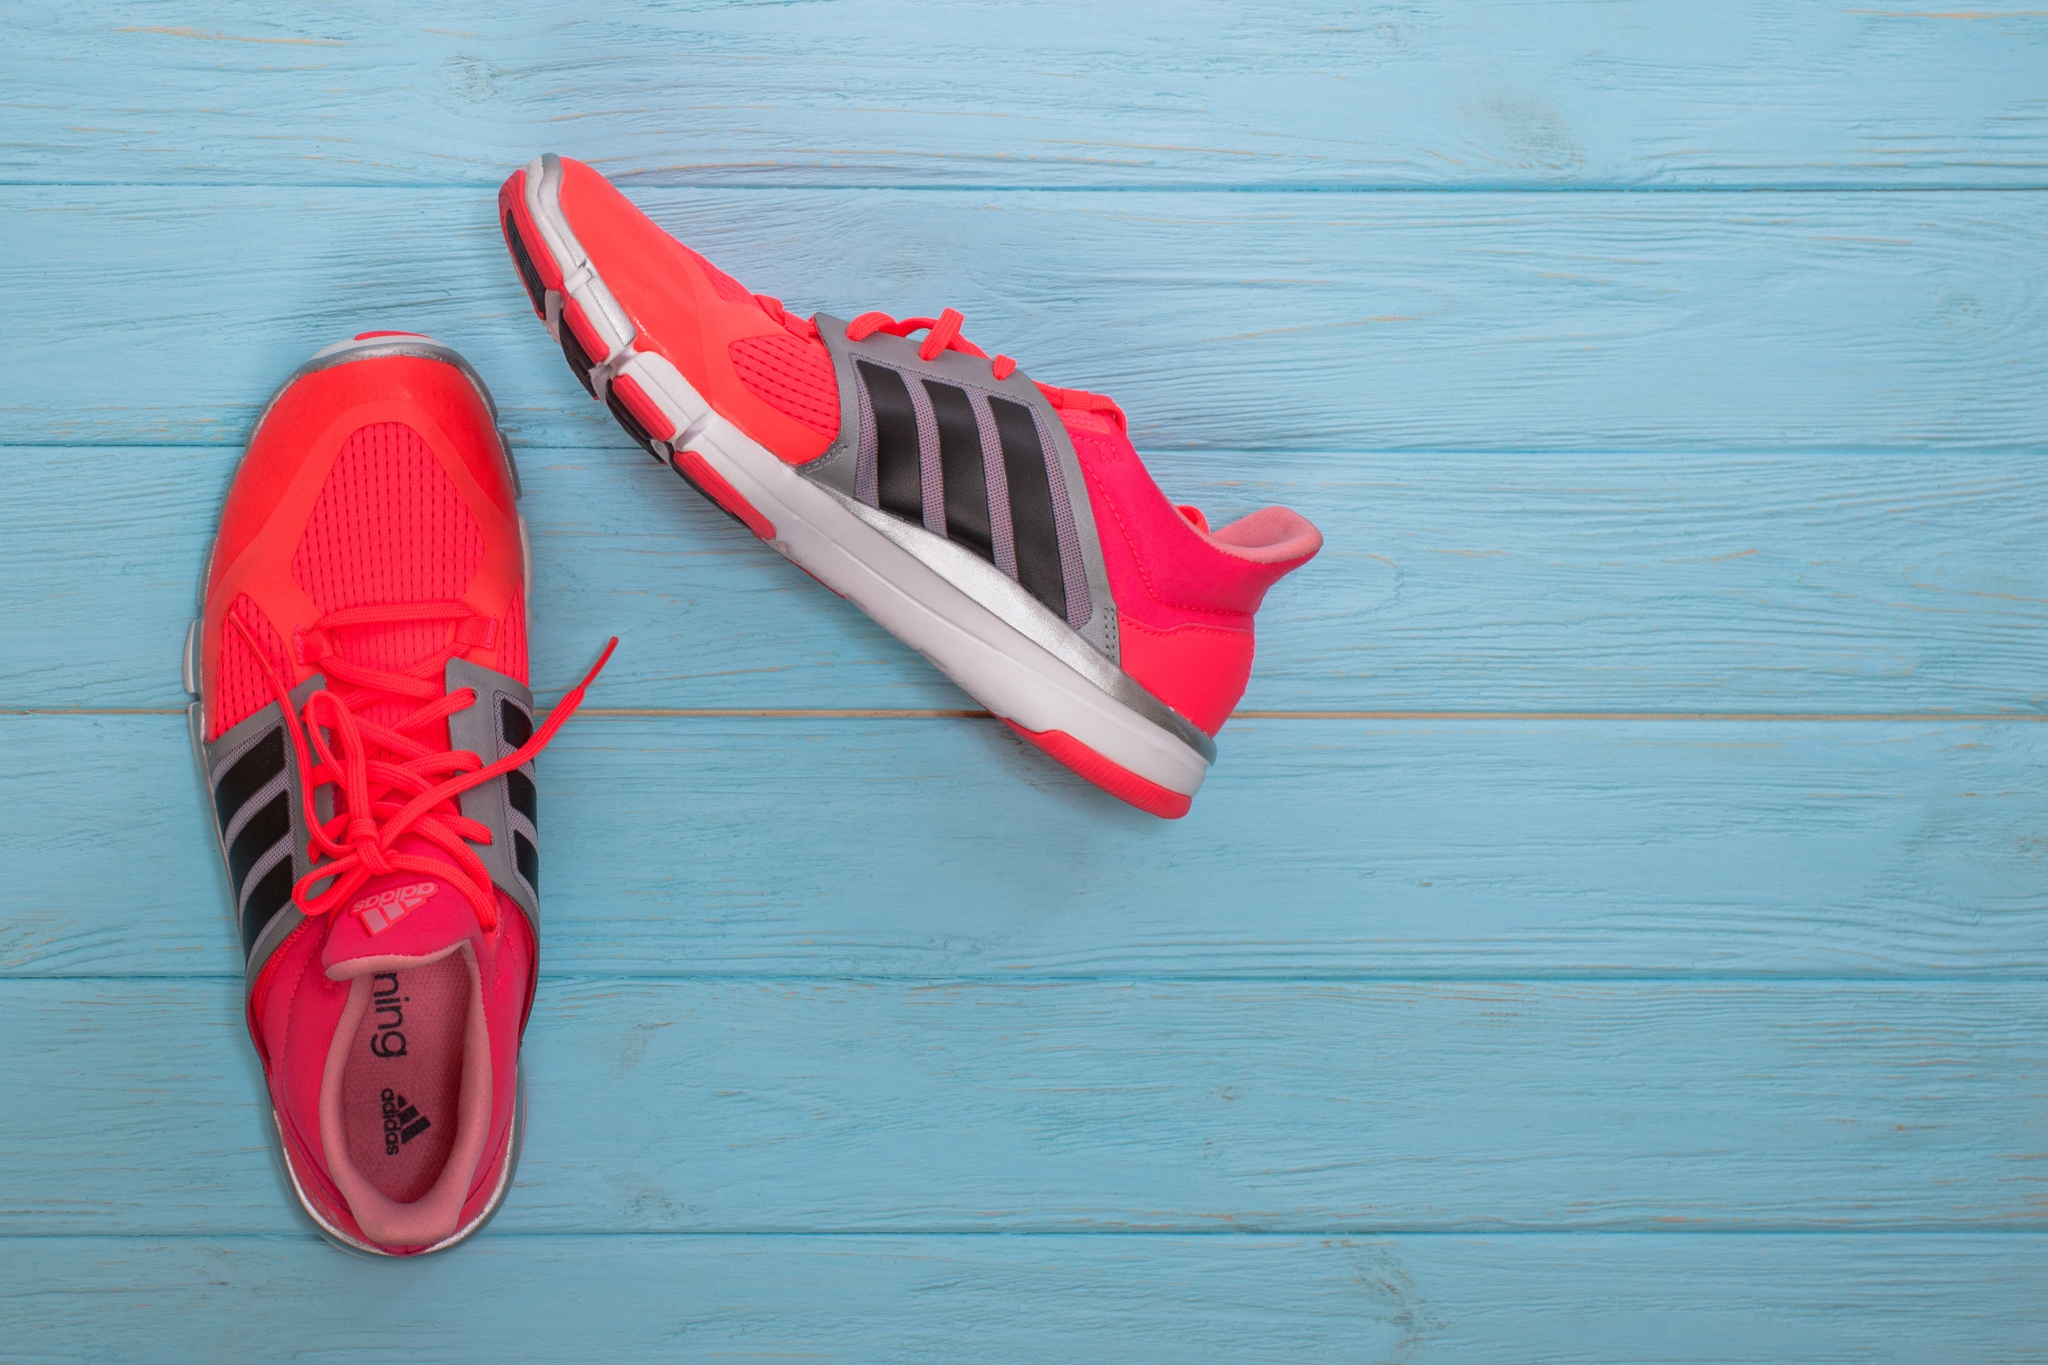What might these shoes say if they could talk? If these shoes could talk, they might say: 'We've been crafted with precision and style, ready for your next adventure. With every step we support, we're not just running shoes; we're your companions on life's journey. We embrace the vibrant red to match your zeal and the black stripes to honor the strength within you. Lace us up, and let's blaze trails and create stories that will last a lifetime.' Describe a realistic scenario where someone might use these shoes for the first time. A fitness enthusiast, Emma, has been eagerly waiting for her new pair of red Adidas running shoes to arrive. After unboxing them with excitement, she decides to take them for their maiden run at dawn. She heads to her favorite park, the air crisp and refreshing. As she laces up her shoes, she feels the perfect snug fit and the cushioning that promises comfort. With every stride, she feels motivated, the vibrant color of the shoes making her feel energized and stylish. The shoes support her through her run, giving her the confidence and comfort she was hoping for, marking the beginning of many more runs and achievements. Imagine a scene in a sci-fi movie where these shoes play a crucial role. Describe it in detail. In a futuristic world where humanity is on the brink of extinction due to a rapidly spreading virus, a brilliant scientist, Dr. Alex Carter, discovers that the key to the cure lies far beyond their contaminated city. The journey to the ancient archives harboring the needed information is perilous, treacherous, and must be covered on foot to avoid detection by rogue drones. Dr. Carter, geared in state-of-the-art equipment, dons a pair of cutting-edge Adidas running shoes infused with nanotechnology. These shoes are not only designed for speed and durability but also equipped with adaptive propulsion mechanisms and stealth mode capabilities. As the scene unfolds, the camera zooms in on Dr. Carter's feet as they effortlessly glide over rugged terrain, the shoes adjusting to each step's force and surface. Through dense forests, abandoned wastelands, and over crumbling infrastructure, the shoes' built-in sensors guide Dr. Carter, optimizing energy use and providing real-time feedback directly to his neural interface. In the gripping climax, with drones hot on his trail and the fate of humanity at stake, these shoes grant Dr. Carter the swift agility and unnoticed passage needed to secure the ancient archives and return with the lifesaving cure. The scene highlights not just a thrilling chase but also showcases the incredible technology embedded within these seemingly simple running shoes, making them a pivotal element in humanity's survival. 